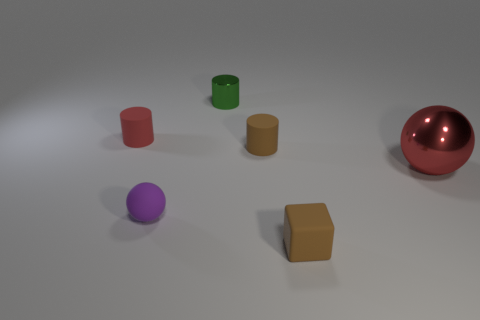Subtract all tiny rubber cylinders. How many cylinders are left? 1 Add 1 big red things. How many objects exist? 7 Subtract all blocks. How many objects are left? 5 Add 3 matte cubes. How many matte cubes are left? 4 Add 4 brown matte cylinders. How many brown matte cylinders exist? 5 Subtract 1 brown blocks. How many objects are left? 5 Subtract all tiny matte spheres. Subtract all red rubber cylinders. How many objects are left? 4 